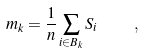Convert formula to latex. <formula><loc_0><loc_0><loc_500><loc_500>m _ { k } = \frac { 1 } { n } \sum _ { i \in B _ { k } } S _ { i } \quad ,</formula> 